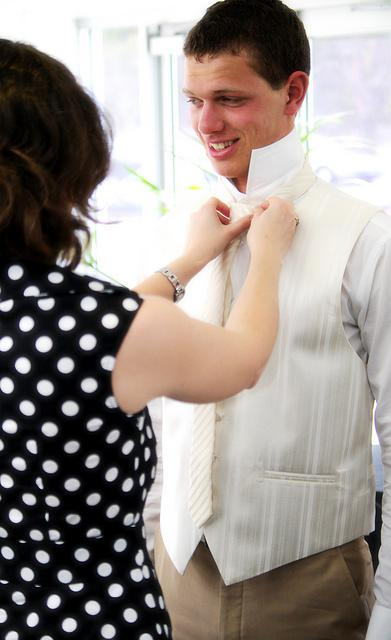What is the woman helping to do? Please explain your reasoning. tie. The woman has her hands near the man's neck which indicates she's helping with his necktie. 